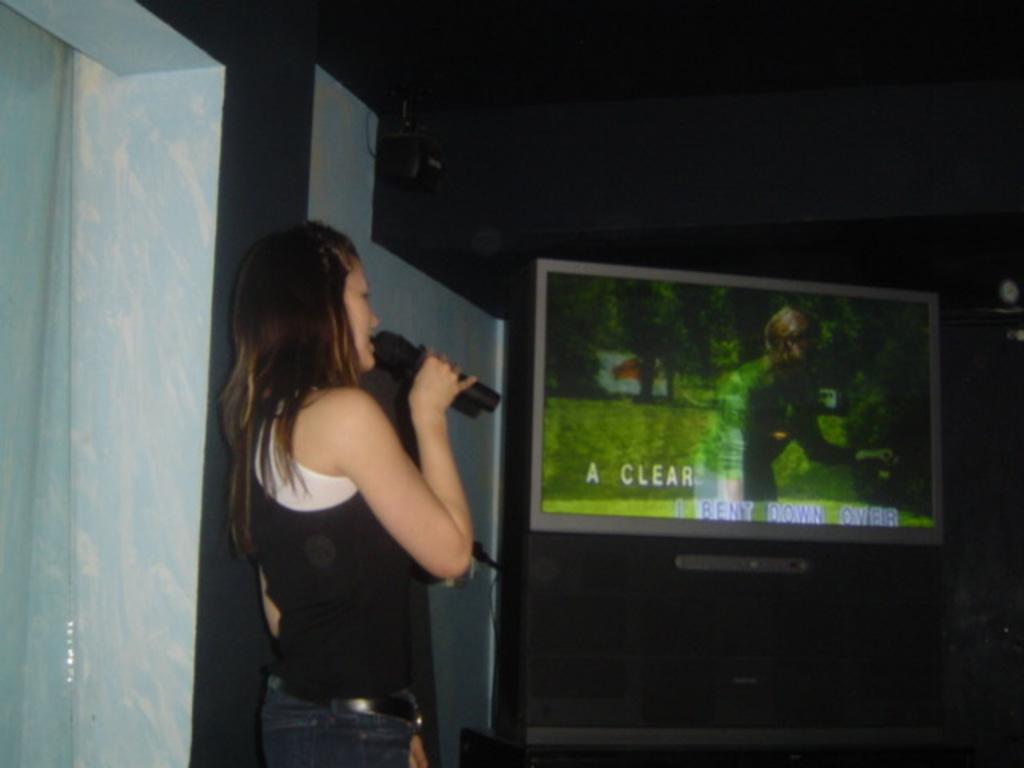What is the woman in the image doing? The woman is standing in the image and holding a microphone in her hand. What can be seen on the left side of the image? There is a screen attached to the wall on the left side of the image. What is attached to the roof at the top of the image? A projector is attached to the roof at the top of the image. Can you see a van parked at the edge of the image? There is no van or edge present in the image. Is there a kitten playing with the microphone in the image? There is no kitten present in the image; the woman is holding the microphone. 